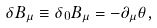<formula> <loc_0><loc_0><loc_500><loc_500>\delta B _ { \mu } \equiv \delta _ { 0 } B _ { \mu } = - \partial _ { \mu } \theta ,</formula> 